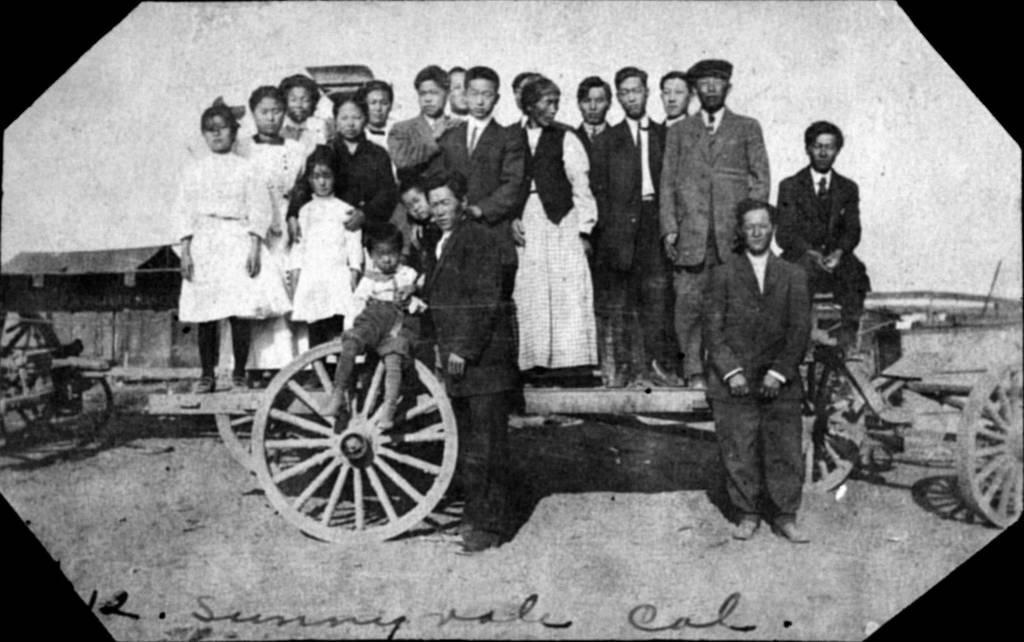Can you describe this image briefly? In this image there are group of persons standing in the center and there is a wheel in the center. On the right side there are wheels and there is a cart. 